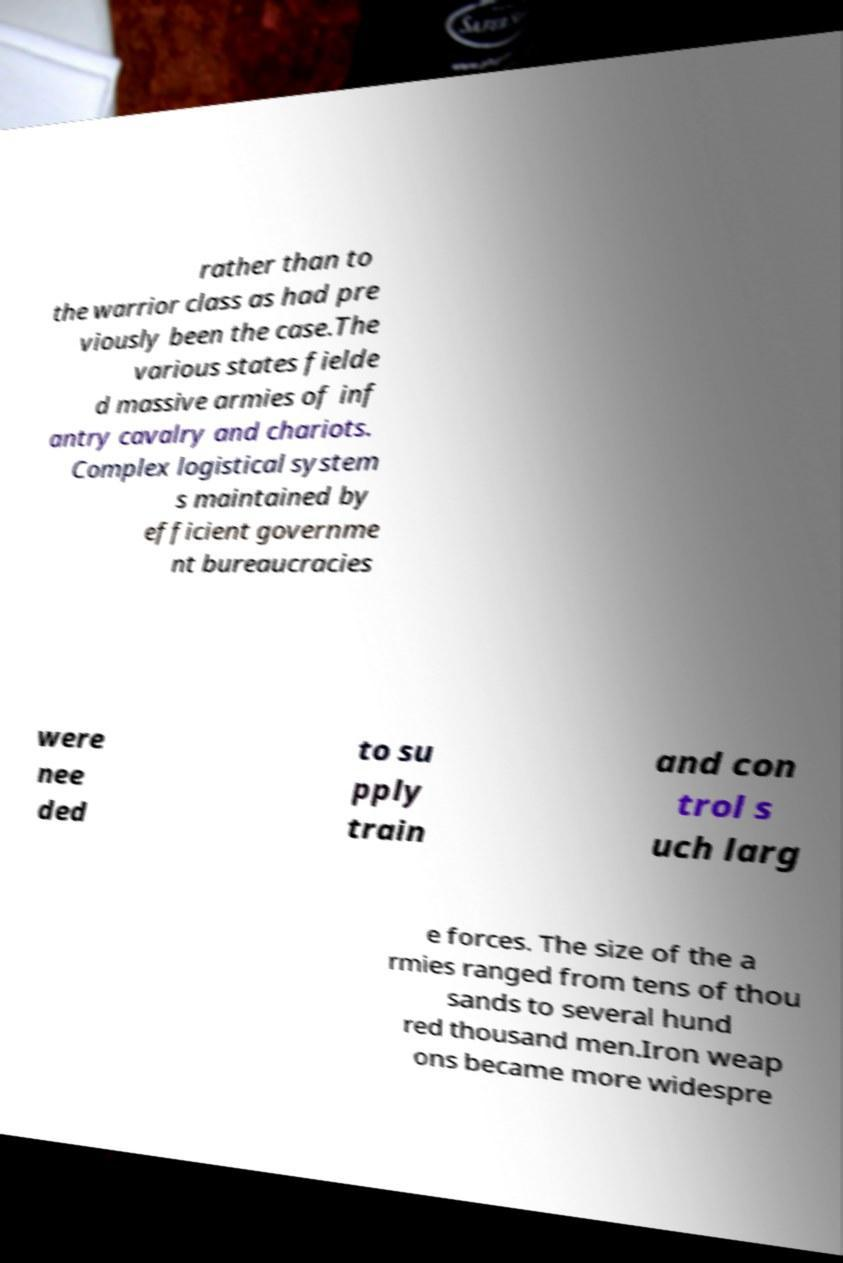For documentation purposes, I need the text within this image transcribed. Could you provide that? rather than to the warrior class as had pre viously been the case.The various states fielde d massive armies of inf antry cavalry and chariots. Complex logistical system s maintained by efficient governme nt bureaucracies were nee ded to su pply train and con trol s uch larg e forces. The size of the a rmies ranged from tens of thou sands to several hund red thousand men.Iron weap ons became more widespre 